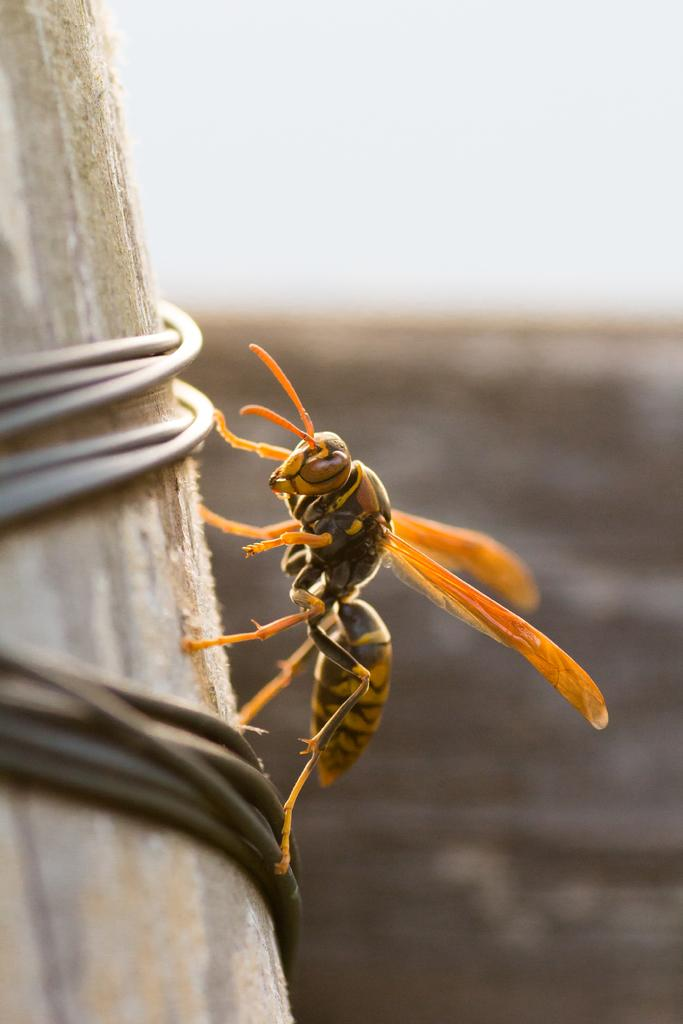What insect is present in the image? There is a hornet in the image. Where is the hornet located? The hornet is on a wooden pole. What can be seen in the background of the image? The sky is visible in the image. How would you describe the weather based on the sky in the image? The sky appears to be cloudy, which might suggest overcast or potentially rainy weather. How many apples are hanging from the wooden pole in the image? There are no apples present in the image; it features a hornet on a wooden pole. What is the mass of the hornet in the image? It is not possible to determine the mass of the hornet from the image alone, as we cannot see its size or compare it to any known objects. 